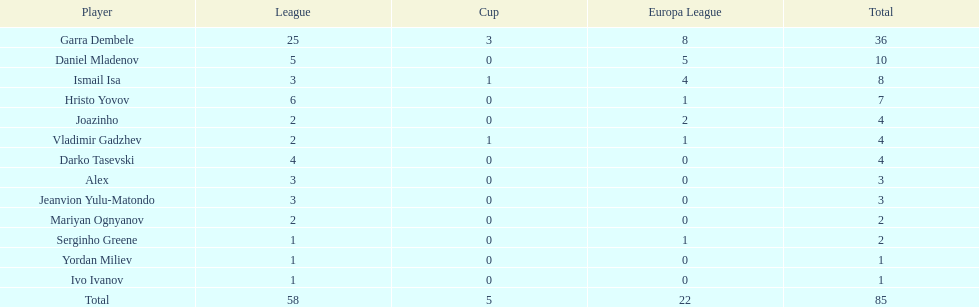In which league do joazinho and vladimir gadzhev share a player? Mariyan Ognyanov. 